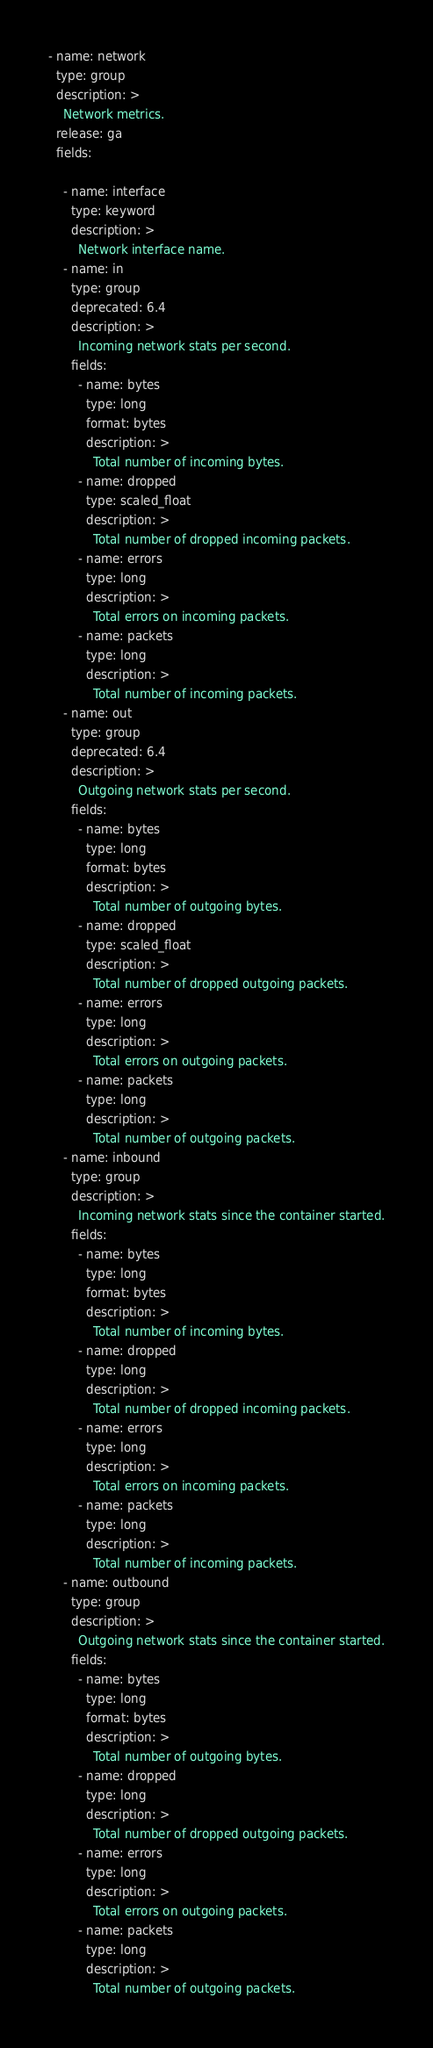<code> <loc_0><loc_0><loc_500><loc_500><_YAML_>- name: network
  type: group
  description: >
    Network metrics.
  release: ga
  fields:

    - name: interface
      type: keyword
      description: >
        Network interface name.
    - name: in
      type: group
      deprecated: 6.4
      description: >
        Incoming network stats per second.
      fields:
        - name: bytes
          type: long
          format: bytes
          description: >
            Total number of incoming bytes.
        - name: dropped
          type: scaled_float
          description: >
            Total number of dropped incoming packets.
        - name: errors
          type: long
          description: >
            Total errors on incoming packets.
        - name: packets
          type: long
          description: >
            Total number of incoming packets.
    - name: out
      type: group
      deprecated: 6.4
      description: >
        Outgoing network stats per second.
      fields:
        - name: bytes
          type: long
          format: bytes
          description: >
            Total number of outgoing bytes.
        - name: dropped
          type: scaled_float
          description: >
            Total number of dropped outgoing packets.
        - name: errors
          type: long
          description: >
            Total errors on outgoing packets.
        - name: packets
          type: long
          description: >
            Total number of outgoing packets.
    - name: inbound
      type: group
      description: >
        Incoming network stats since the container started.
      fields:
        - name: bytes
          type: long
          format: bytes
          description: >
            Total number of incoming bytes.
        - name: dropped
          type: long
          description: >
            Total number of dropped incoming packets.
        - name: errors
          type: long
          description: >
            Total errors on incoming packets.
        - name: packets
          type: long
          description: >
            Total number of incoming packets.
    - name: outbound
      type: group
      description: >
        Outgoing network stats since the container started.
      fields:
        - name: bytes
          type: long
          format: bytes
          description: >
            Total number of outgoing bytes.
        - name: dropped
          type: long
          description: >
            Total number of dropped outgoing packets.
        - name: errors
          type: long
          description: >
            Total errors on outgoing packets.
        - name: packets
          type: long
          description: >
            Total number of outgoing packets.
</code> 